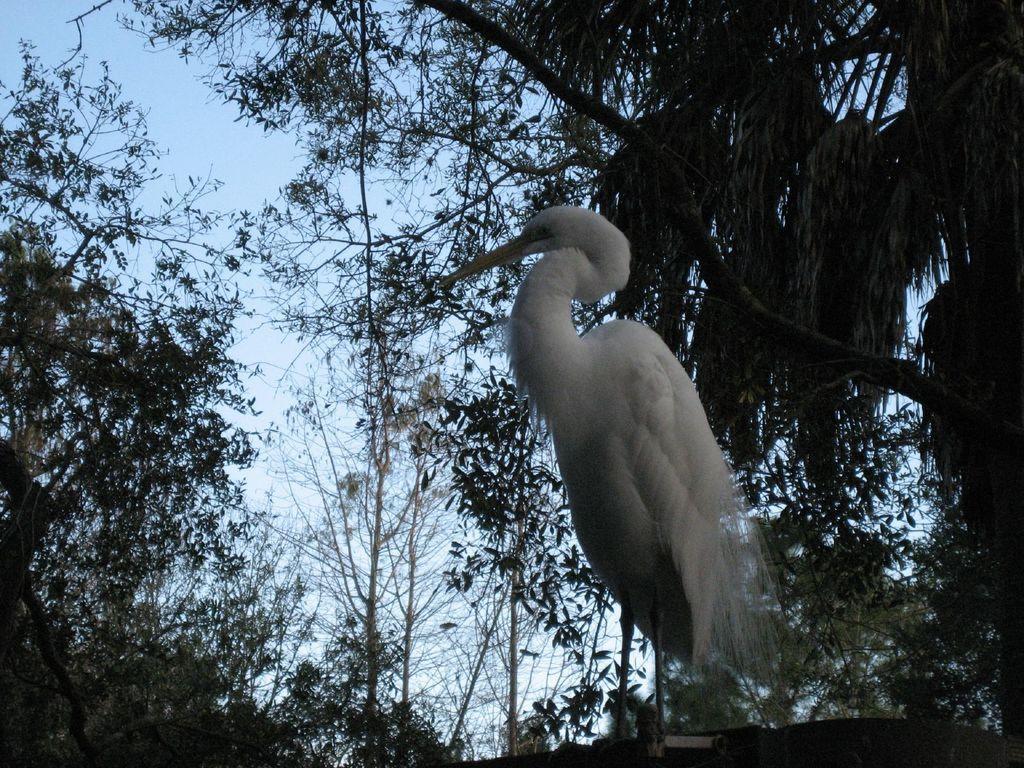Please provide a concise description of this image. In this image I can see a bird which is white in color. In the background I can see few trees and the sky. 